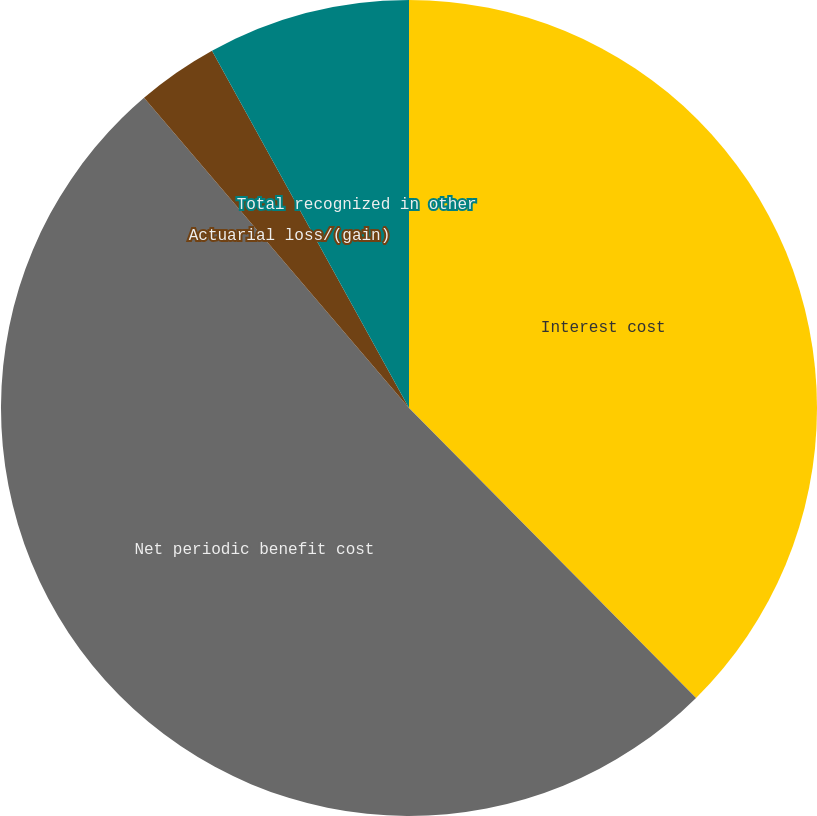Convert chart to OTSL. <chart><loc_0><loc_0><loc_500><loc_500><pie_chart><fcel>Interest cost<fcel>Net periodic benefit cost<fcel>Actuarial loss/(gain)<fcel>Total recognized in other<nl><fcel>37.58%<fcel>51.17%<fcel>3.23%<fcel>8.02%<nl></chart> 